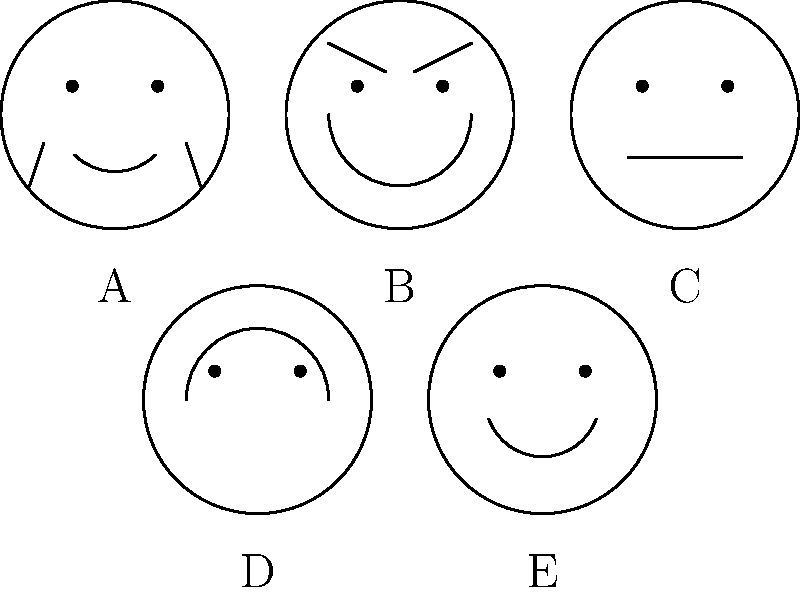As a psychotherapist working with clients who are searching for missing family members, it's crucial to recognize various expressions of distress. In the image above, which face most accurately represents the emotional state of a person who has just received inconclusive information about their missing loved one's whereabouts? To answer this question, we need to analyze each face and consider the emotional state it represents in the context of receiving inconclusive information about a missing loved one:

1. Face A: Shows tears and a slight frown, indicating sadness and distress.
2. Face B: Displays a deep frown and furrowed eyebrows, suggesting intense worry or anguish.
3. Face C: Has a neutral expression with a straight line for a mouth, implying emotional numbness or shock.
4. Face D: Shows a smile, which is inappropriate for the given situation.
5. Face E: Depicts a slight smile, also unsuitable for the described scenario.

Given the situation of receiving inconclusive information about a missing loved one, the most likely emotional responses would be:

1. Distress and sadness (represented by Face A)
2. Intense worry or anguish (represented by Face B)
3. Shock or emotional numbness (represented by Face C)

Among these, Face B most accurately captures the intense worry and anguish that would likely be experienced in this situation. The deep frown and furrowed eyebrows indicate a strong negative emotion, which aligns with the uncertainty and concern one would feel upon receiving inconclusive information about a missing family member.

While Face A (sadness) and Face C (shock) are also plausible reactions, the intensity of emotion shown in Face B best matches the gravity of the situation described in the question.
Answer: B 